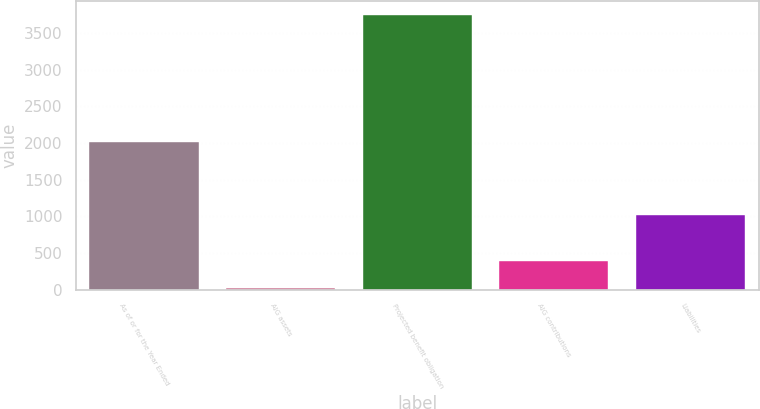Convert chart. <chart><loc_0><loc_0><loc_500><loc_500><bar_chart><fcel>As of or for the Year Ended<fcel>AIG assets<fcel>Projected benefit obligation<fcel>AIG contributions<fcel>Liabilities<nl><fcel>2008<fcel>25<fcel>3745<fcel>397<fcel>1012<nl></chart> 